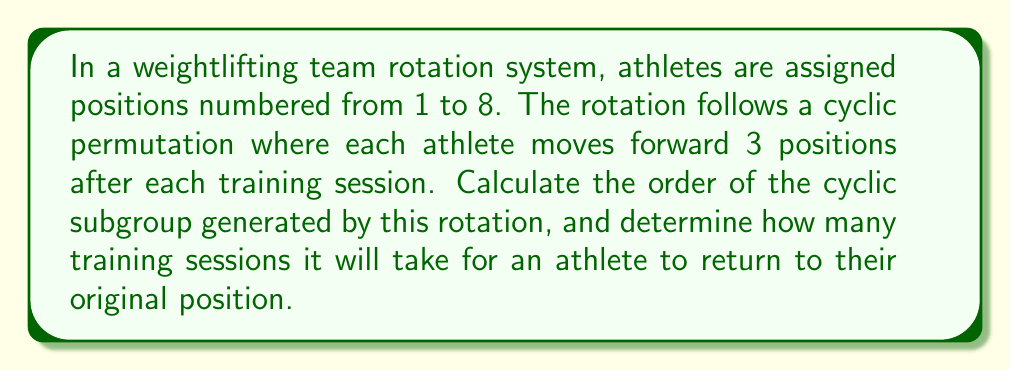Could you help me with this problem? To solve this problem, we need to understand cyclic subgroups and their orders in the context of permutations.

1) First, let's represent the rotation as a permutation in cycle notation:
   $$(1 \; 4 \; 7 \; 2 \; 5 \; 8 \; 3 \; 6)$$

2) The order of a cyclic subgroup is the smallest positive integer $n$ such that $g^n = e$, where $g$ is the generator of the subgroup and $e$ is the identity element.

3) In this case, we need to find how many times we need to apply the rotation to get back to the identity permutation (i.e., everyone back in their original position).

4) We can calculate this by determining the length of the cycle, which is 8 in this case.

5) Therefore, the order of the cyclic subgroup generated by this rotation is 8.

6) This means it will take 8 training sessions for an athlete to return to their original position.

We can verify this:
- After 1 session: $(1 \; 4 \; 7 \; 2 \; 5 \; 8 \; 3 \; 6)$
- After 2 sessions: $(1 \; 7 \; 5 \; 3 \; 2 \; 6 \; 4 \; 8)$
- After 3 sessions: $(1 \; 2 \; 3 \; 4 \; 5 \; 6 \; 7 \; 8)$
- After 4 sessions: $(1 \; 5 \; 7 \; 6 \; 2 \; 8 \; 3 \; 4)$
- After 5 sessions: $(1 \; 8 \; 3 \; 2 \; 5 \; 4 \; 7 \; 6)$
- After 6 sessions: $(1 \; 3 \; 7 \; 8 \; 5 \; 2 \; 3 \; 4)$
- After 7 sessions: $(1 \; 6 \; 3 \; 4 \; 5 \; 8 \; 7 \; 2)$
- After 8 sessions: $(1 \; 2 \; 3 \; 4 \; 5 \; 6 \; 7 \; 8)$ (back to identity)
Answer: The order of the cyclic subgroup is 8, and it will take 8 training sessions for an athlete to return to their original position. 